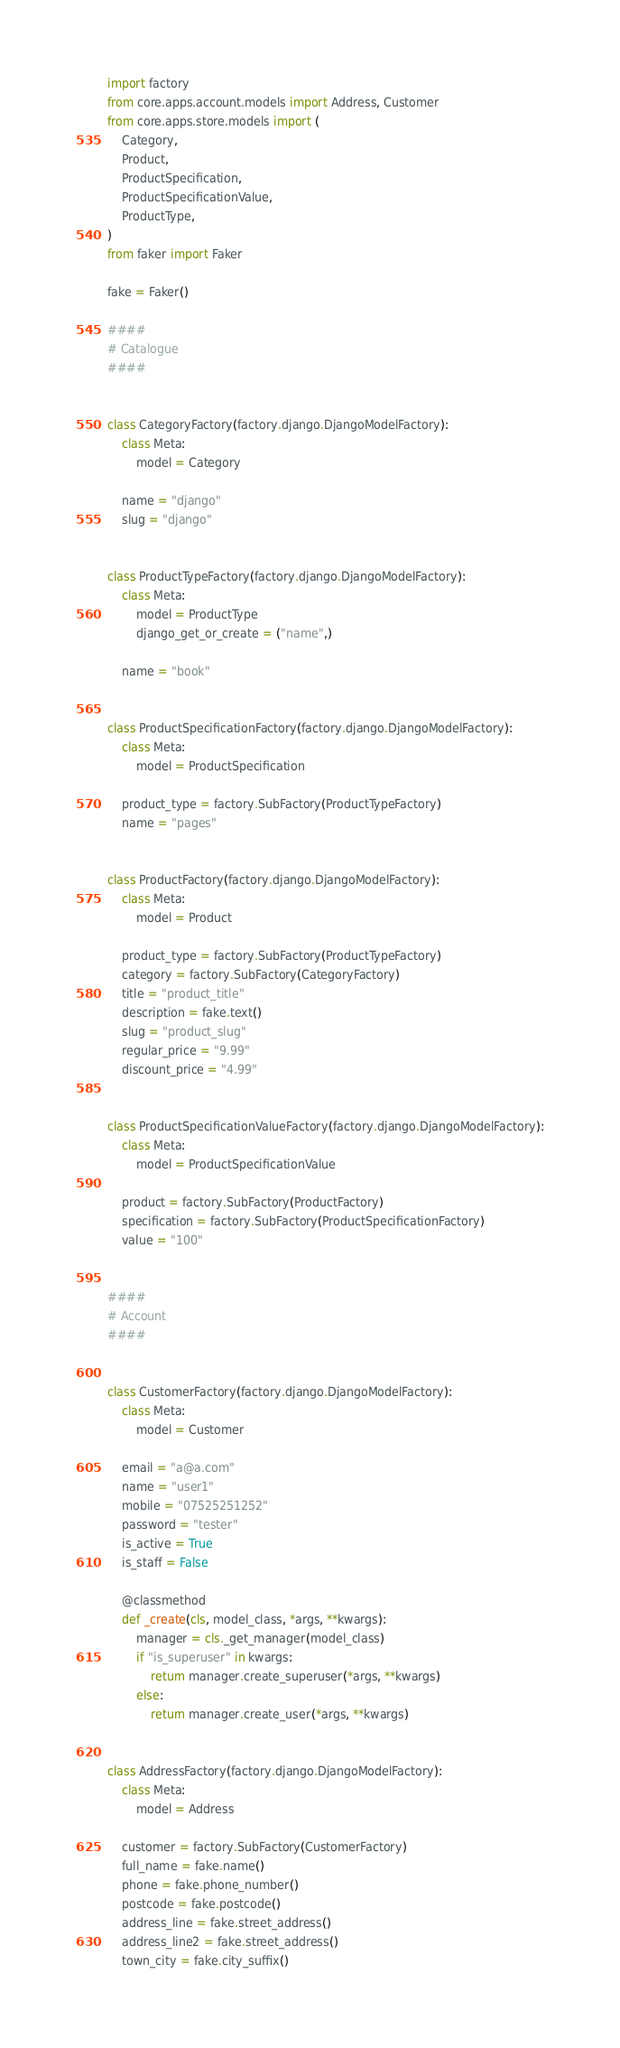Convert code to text. <code><loc_0><loc_0><loc_500><loc_500><_Python_>import factory
from core.apps.account.models import Address, Customer
from core.apps.store.models import (
    Category,
    Product,
    ProductSpecification,
    ProductSpecificationValue,
    ProductType,
)
from faker import Faker

fake = Faker()

####
# Catalogue
####


class CategoryFactory(factory.django.DjangoModelFactory):
    class Meta:
        model = Category

    name = "django"
    slug = "django"


class ProductTypeFactory(factory.django.DjangoModelFactory):
    class Meta:
        model = ProductType
        django_get_or_create = ("name",)

    name = "book"


class ProductSpecificationFactory(factory.django.DjangoModelFactory):
    class Meta:
        model = ProductSpecification

    product_type = factory.SubFactory(ProductTypeFactory)
    name = "pages"


class ProductFactory(factory.django.DjangoModelFactory):
    class Meta:
        model = Product

    product_type = factory.SubFactory(ProductTypeFactory)
    category = factory.SubFactory(CategoryFactory)
    title = "product_title"
    description = fake.text()
    slug = "product_slug"
    regular_price = "9.99"
    discount_price = "4.99"


class ProductSpecificationValueFactory(factory.django.DjangoModelFactory):
    class Meta:
        model = ProductSpecificationValue

    product = factory.SubFactory(ProductFactory)
    specification = factory.SubFactory(ProductSpecificationFactory)
    value = "100"


####
# Account
####


class CustomerFactory(factory.django.DjangoModelFactory):
    class Meta:
        model = Customer

    email = "a@a.com"
    name = "user1"
    mobile = "07525251252"
    password = "tester"
    is_active = True
    is_staff = False

    @classmethod
    def _create(cls, model_class, *args, **kwargs):
        manager = cls._get_manager(model_class)
        if "is_superuser" in kwargs:
            return manager.create_superuser(*args, **kwargs)
        else:
            return manager.create_user(*args, **kwargs)


class AddressFactory(factory.django.DjangoModelFactory):
    class Meta:
        model = Address

    customer = factory.SubFactory(CustomerFactory)
    full_name = fake.name()
    phone = fake.phone_number()
    postcode = fake.postcode()
    address_line = fake.street_address()
    address_line2 = fake.street_address()
    town_city = fake.city_suffix()</code> 